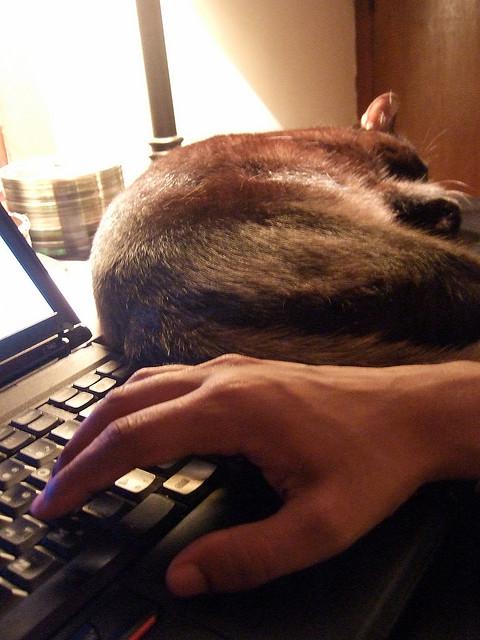What is the cat doing?
Short answer required. Sleeping. How many cats are the person's arm?
Write a very short answer. 1. Is this a right or left hand?
Concise answer only. Right. Where is the cat?
Short answer required. Desk. 